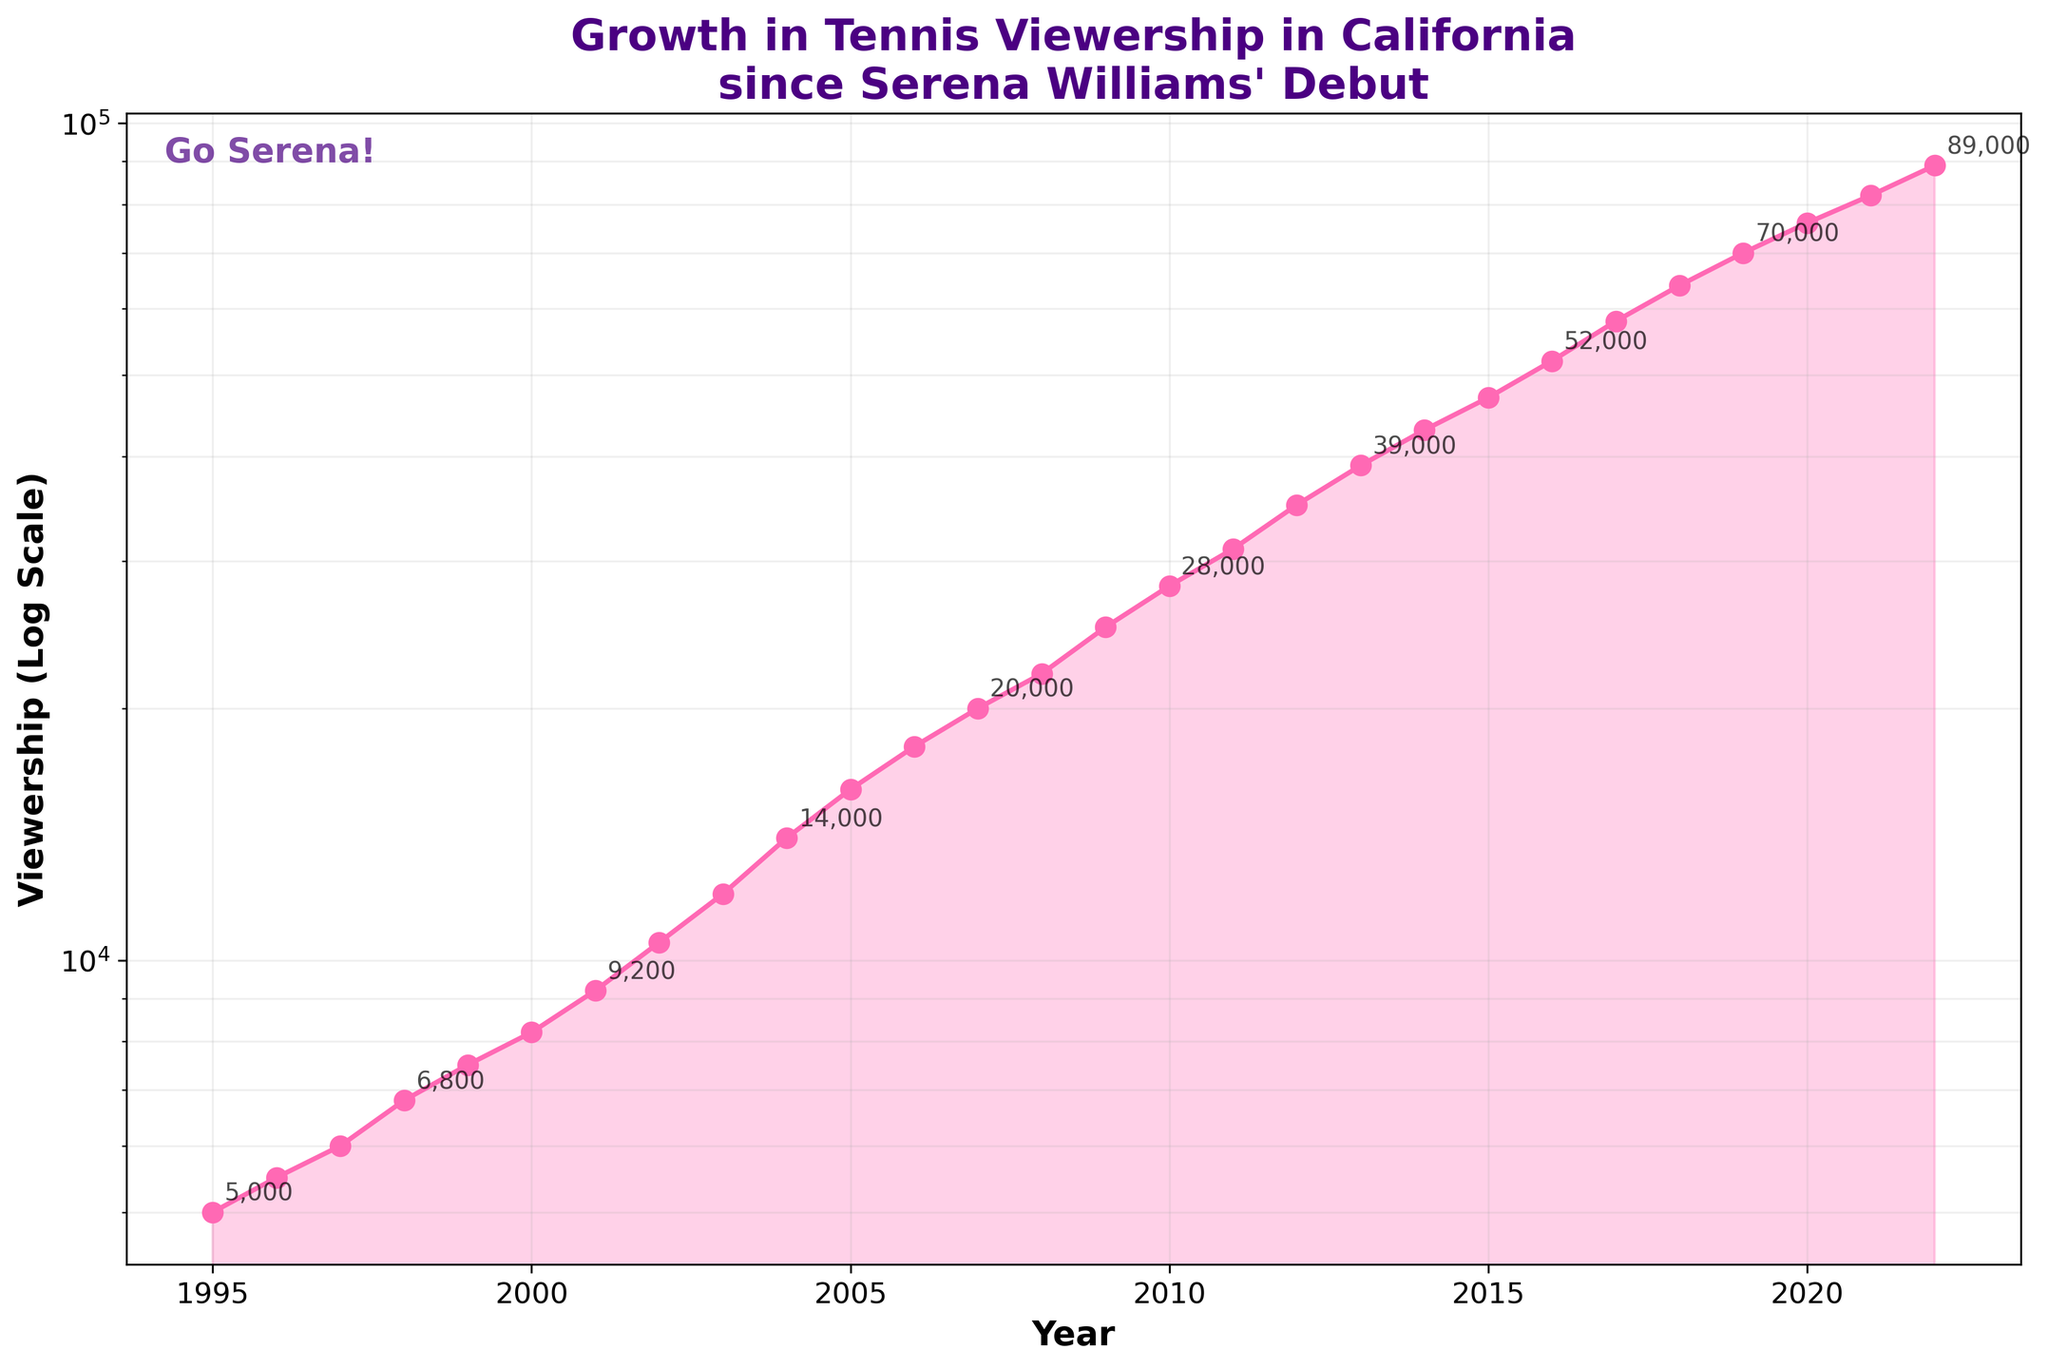What is the title of the plot? The title is displayed at the top of the plot. It reads "Growth in Tennis Viewership in California since Serena Williams' Debut."
Answer: Growth in Tennis Viewership in California since Serena Williams' Debut What are the units on the Y-axis? The Y-axis label indicates the units. It is labeled as "Viewership (Log Scale)."
Answer: Viewership (Log Scale) During which years did viewership first exceed 10,000? The point where the viewership data crosses the 10,000 mark on the y-axis indicates the first year it exceeded this number. The plot shows it exceeded 10,000 between 2001 and 2002.
Answer: 2002 Is the rate of growth increasing, decreasing, or constant over the period? By observing the angle and the spacing of the markers on the log scale, we can assess the rate of growth. A steeper curve or reducing gaps would indicate increasing growth, while widening gaps would indicate decreasing growth. The spacing in the viewership on the log scale plot indicates a generally increasing rate of growth.
Answer: Increasing How much did viewership increase between 2016 and 2017? Subtract the viewership in 2016 from the viewership in 2017. According to the plot, viewership in 2016 was 52,000, and in 2017 it was 58,000. Therefore, the increase is 58,000 - 52,000.
Answer: 6,000 Which year shows the highest viewership? Locate the point with the highest vertical position on the plot. The highest data point appears at the top (end) of the graph. This corresponds to the year 2022.
Answer: 2022 What is the approximate viewership in the year 2000? Locate the data marker for the year 2000 on the x-axis and read the value on the y-axis. The viewership in the year 2000 appears to be about 8,200.
Answer: 8,200 How does the growth pattern change after 2010? Compare the section of the plot before and after 2010. The spacing and slope of data points can be used as indicators. There appears to be an increased rate of growth after 2010 as the curve steepens.
Answer: Increased rate of growth What's the average viewership between 2017 and 2021? Determine the viewership values for 2017 through 2021 and then calculate their average. The values are 58,000, 64,000, 70,000, 76,000, and 82,000. Summing these gives 350,000, and dividing by 5 gives an average of 70,000.
Answer: 70,000 